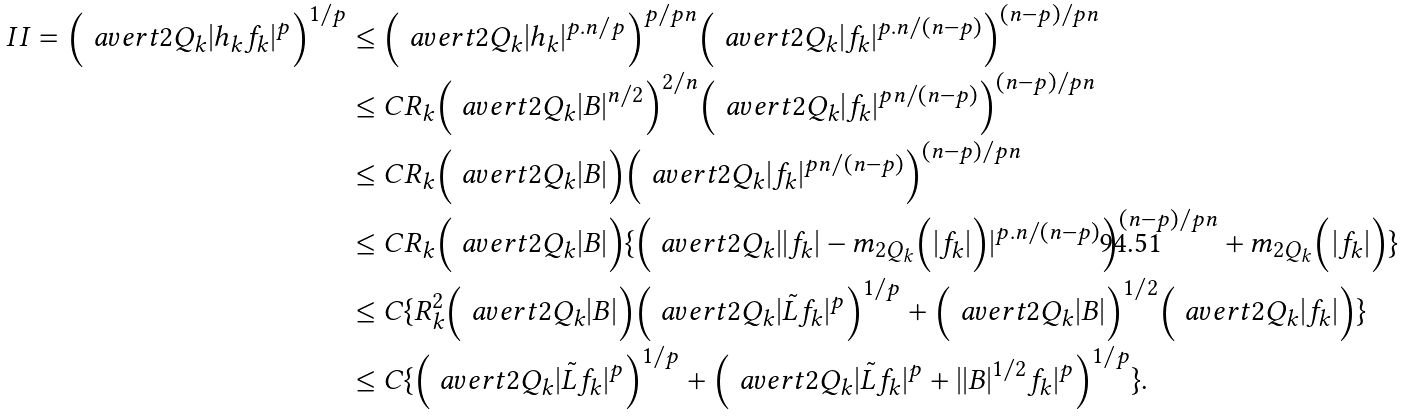Convert formula to latex. <formula><loc_0><loc_0><loc_500><loc_500>I I = \Big { ( } \ a v e r t { 2 Q _ { k } } | h _ { k } f _ { k } | ^ { p } \Big { ) } ^ { 1 / p } & \leq \Big { ( } \ a v e r t { 2 Q _ { k } } | h _ { k } | ^ { p . n / p } \Big { ) } ^ { p / p n } \Big { ( } \ a v e r t { 2 Q _ { k } } | f _ { k } | ^ { p . n / ( n - p ) } \Big { ) } ^ { ( n - p ) / p n } \\ & \leq C R _ { k } \Big { ( } \ a v e r t { 2 Q _ { k } } | B | ^ { n / 2 } \Big { ) } ^ { 2 / n } \Big { ( } \ a v e r t { 2 Q _ { k } } | f _ { k } | ^ { p n / ( n - p ) } \Big { ) } ^ { ( n - p ) / p n } \\ & \leq C R _ { k } \Big { ( } \ a v e r t { 2 Q _ { k } } | B | \Big { ) } \Big { ( } \ a v e r t { 2 Q _ { k } } | f _ { k } | ^ { p n / ( n - p ) } \Big { ) } ^ { ( n - p ) / p n } \\ & \leq C R _ { k } \Big { ( } \ a v e r t { 2 Q _ { k } } | B | \Big { ) } \{ \Big { ( } \ a v e r t { 2 Q _ { k } } | | f _ { k } | - m _ { 2 Q _ { k } } \Big { ( } | f _ { k } | \Big { ) } | ^ { p . n / ( n - p ) } \Big { ) } ^ { ( n - p ) / p n } + m _ { 2 Q _ { k } } \Big { ( } | f _ { k } | \Big { ) } \} \\ & \leq C \{ R _ { k } ^ { 2 } \Big { ( } \ a v e r t { 2 Q _ { k } } | B | \Big { ) } \Big { ( } \ a v e r t { 2 Q _ { k } } | \tilde { L } f _ { k } | ^ { p } \Big { ) } ^ { 1 / p } + \Big { ( } \ a v e r t { 2 Q _ { k } } | B | \Big { ) } ^ { 1 / 2 } \Big { ( } \ a v e r t { 2 Q _ { k } } | f _ { k } | \Big { ) } \} \\ & \leq C \{ \Big { ( } \ a v e r t { 2 Q _ { k } } | \tilde { L } f _ { k } | ^ { p } \Big { ) } ^ { 1 / p } + \Big { ( } \ a v e r t { 2 Q _ { k } } | \tilde { L } f _ { k } | ^ { p } + | | B | ^ { 1 / 2 } f _ { k } | ^ { p } \Big { ) } ^ { 1 / p } \} .</formula> 